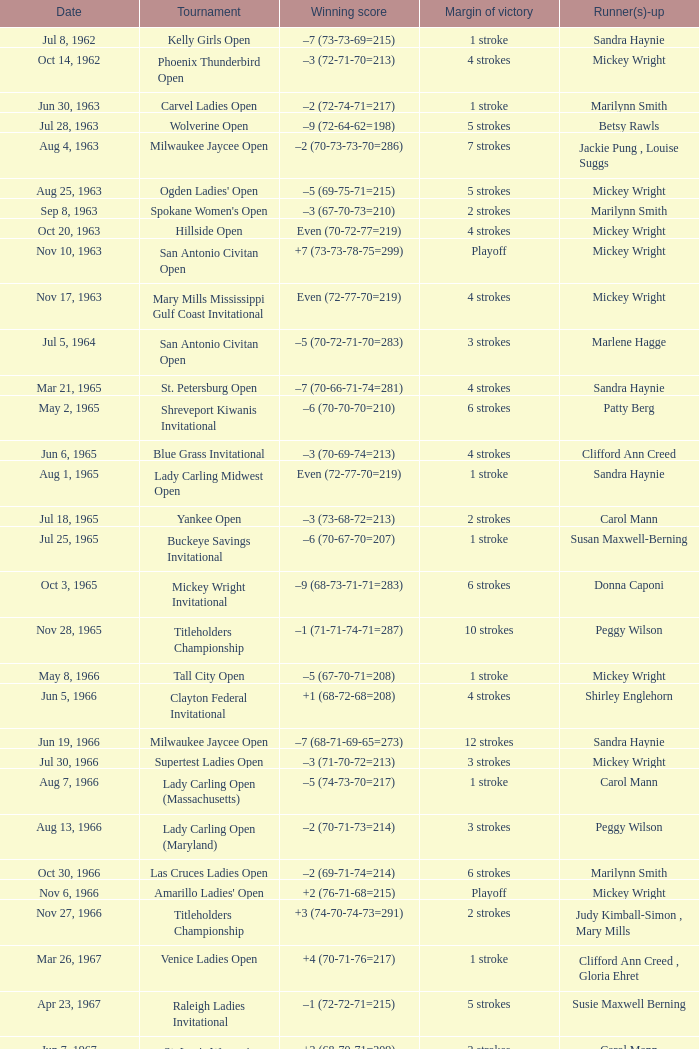What was the triumphing score when there were 9 strokes of superiority? –7 (73-68-73-67=281). 